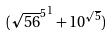<formula> <loc_0><loc_0><loc_500><loc_500>( { \sqrt { 5 6 } ^ { 5 } } ^ { 1 } + 1 0 ^ { \sqrt { 5 } } )</formula> 